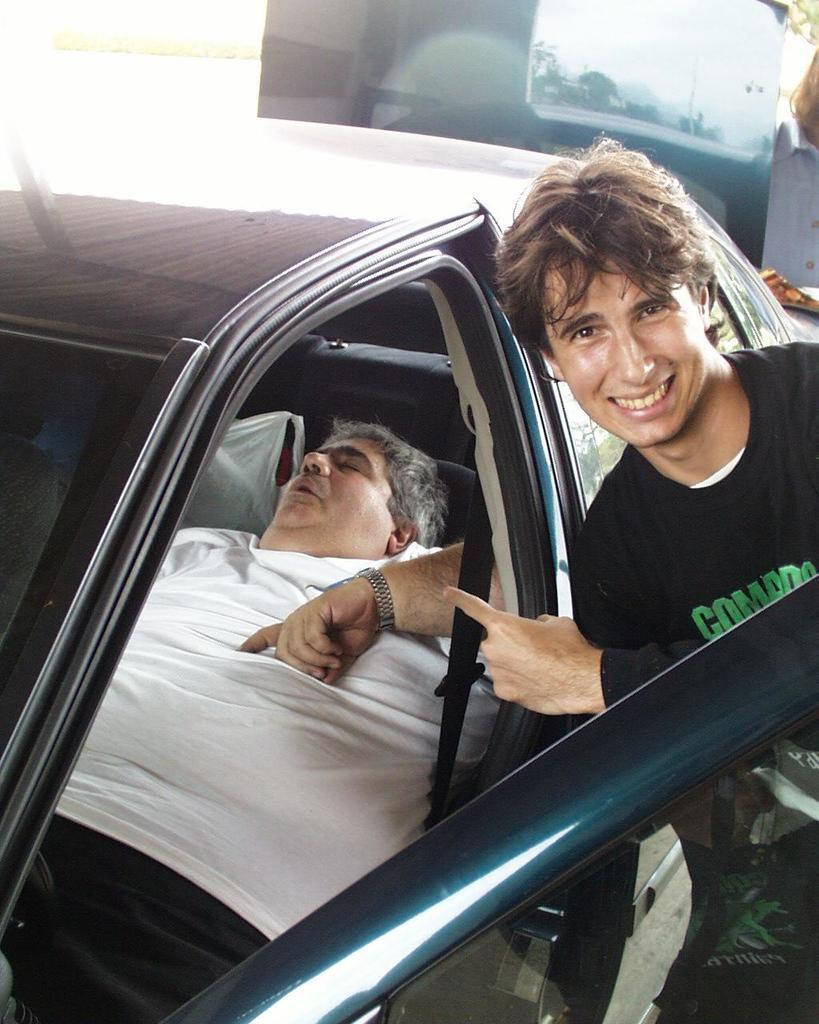Who is present in the image? There is a man in the picture. What is the man in the picture doing? The man is smiling. Are there any other people in the image? Yes, there is another man in the car seat. What is the second man in the car seat doing? The man in the car seat is sleeping. What country is the man visiting in the image? There is no information about the country in the image. How many boys are present in the image? The image only features two men, not boys. 